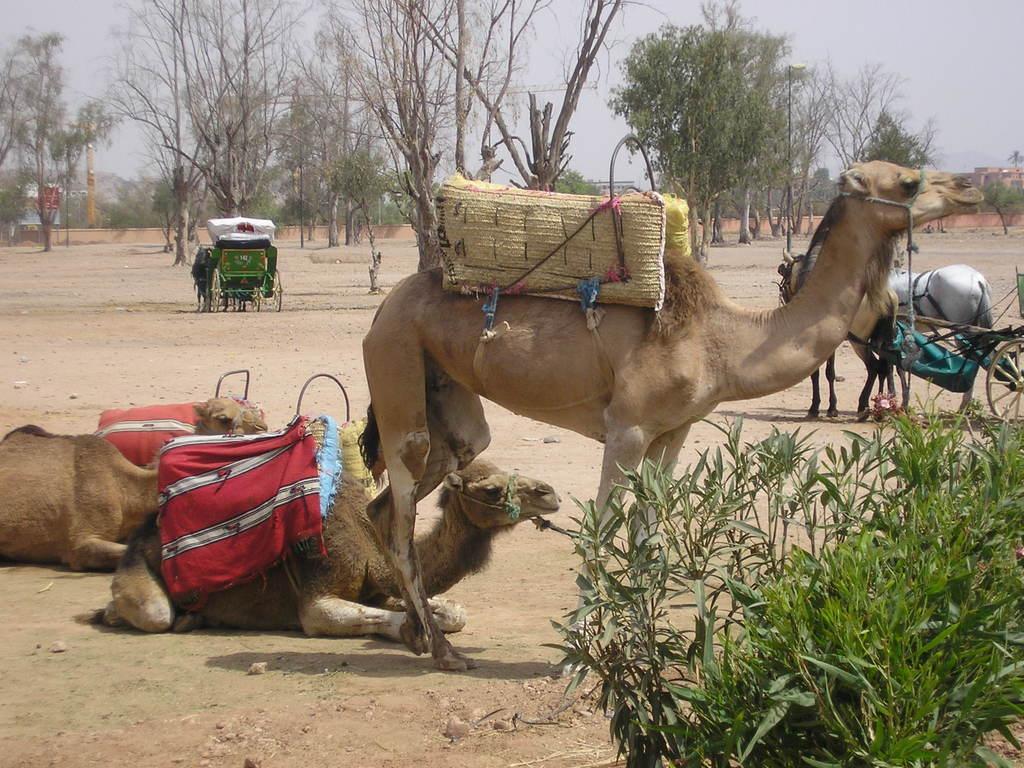Please provide a concise description of this image. In the right side a camel is standing and in the left side 2 camels are sitting, there are trees in the middle of an image. 